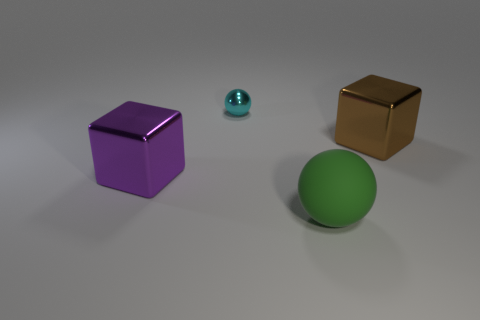There is a object that is both to the left of the big brown metallic cube and on the right side of the small cyan thing; what material is it?
Ensure brevity in your answer.  Rubber. What material is the green ball that is the same size as the brown metallic block?
Your answer should be very brief. Rubber. There is a block to the right of the big shiny thing in front of the large metallic object to the right of the small cyan shiny sphere; what is its size?
Offer a very short reply. Large. There is a cyan thing that is the same material as the brown cube; what size is it?
Keep it short and to the point. Small. Is the size of the purple thing the same as the metallic thing that is on the right side of the tiny metal thing?
Offer a very short reply. Yes. The tiny cyan metallic object that is to the left of the big green matte object has what shape?
Keep it short and to the point. Sphere. There is a big metal cube that is behind the metal object that is left of the cyan thing; is there a big purple thing behind it?
Keep it short and to the point. No. There is a green thing that is the same shape as the cyan thing; what is its material?
Make the answer very short. Rubber. Is there any other thing that has the same material as the big green sphere?
Your answer should be compact. No. How many cubes are either tiny objects or large green rubber objects?
Ensure brevity in your answer.  0. 